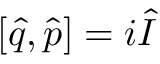Convert formula to latex. <formula><loc_0><loc_0><loc_500><loc_500>[ \hat { q } , \hat { p } ] = i \hat { I }</formula> 